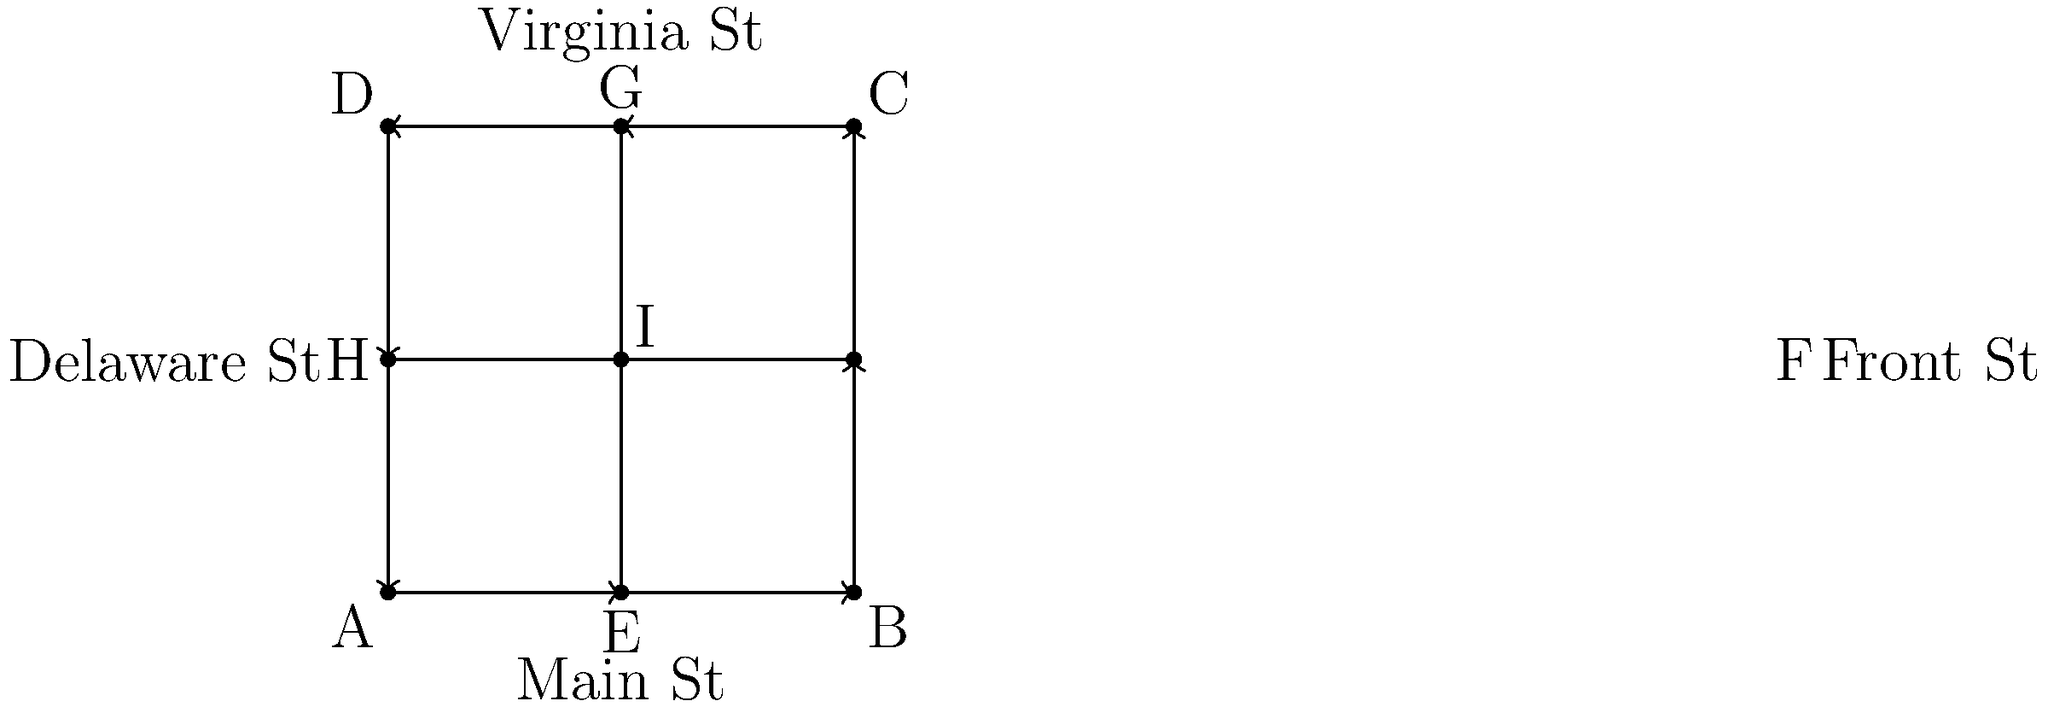Based on the simplified map of Conrad's historic district, what is the total number of four-way intersections, and how many blocks does a vehicle need to travel to complete a full circuit around the outer perimeter of the district? To answer this question, we need to analyze the map step-by-step:

1. Counting four-way intersections:
   - The map shows 9 labeled points (A through I).
   - Point I is clearly a four-way intersection.
   - Points E, F, G, and H are also four-way intersections.
   - Total number of four-way intersections: 5

2. Calculating blocks traveled for a full circuit:
   - The outer perimeter of the district is formed by the square ABCD.
   - Each side of the square represents one block.
   - To complete a full circuit, a vehicle must travel all four sides.
   - Number of blocks = 4

Therefore, there are 5 four-way intersections, and a vehicle needs to travel 4 blocks to complete a full circuit around the outer perimeter of the historic district.
Answer: 5 intersections; 4 blocks 